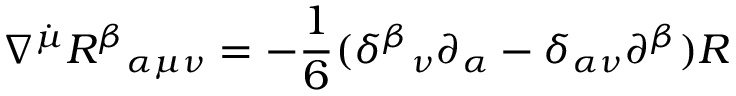Convert formula to latex. <formula><loc_0><loc_0><loc_500><loc_500>\nabla ^ { \dot { \mu } } R ^ { \beta _ { \alpha \mu \nu } = - \frac { 1 } { 6 } ( \delta ^ { \beta _ { \nu } \partial _ { \alpha } - \delta _ { \alpha \nu } \partial ^ { \beta } ) R</formula> 